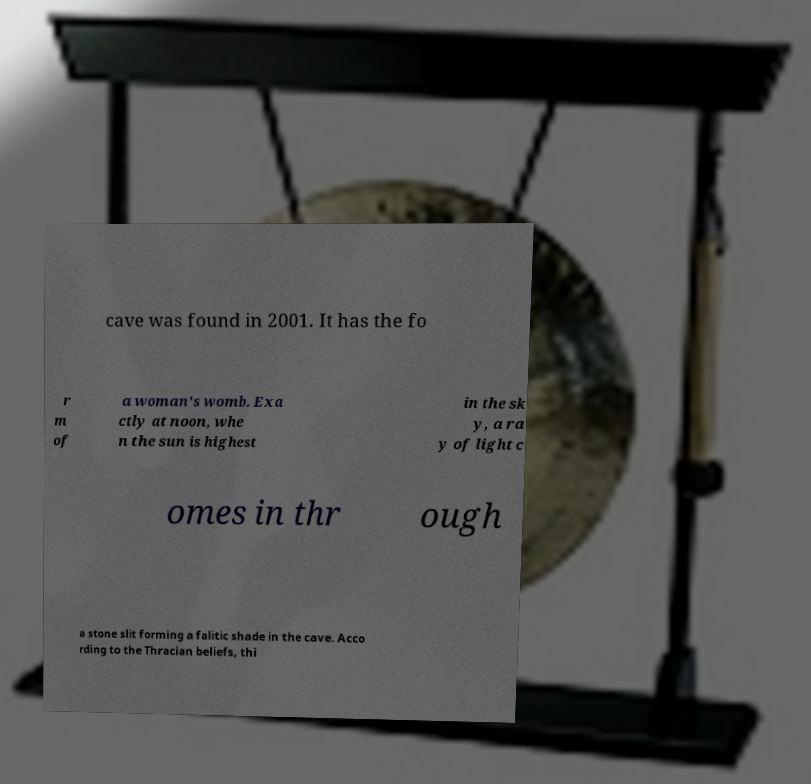For documentation purposes, I need the text within this image transcribed. Could you provide that? cave was found in 2001. It has the fo r m of a woman's womb. Exa ctly at noon, whe n the sun is highest in the sk y, a ra y of light c omes in thr ough a stone slit forming a falitic shade in the cave. Acco rding to the Thracian beliefs, thi 